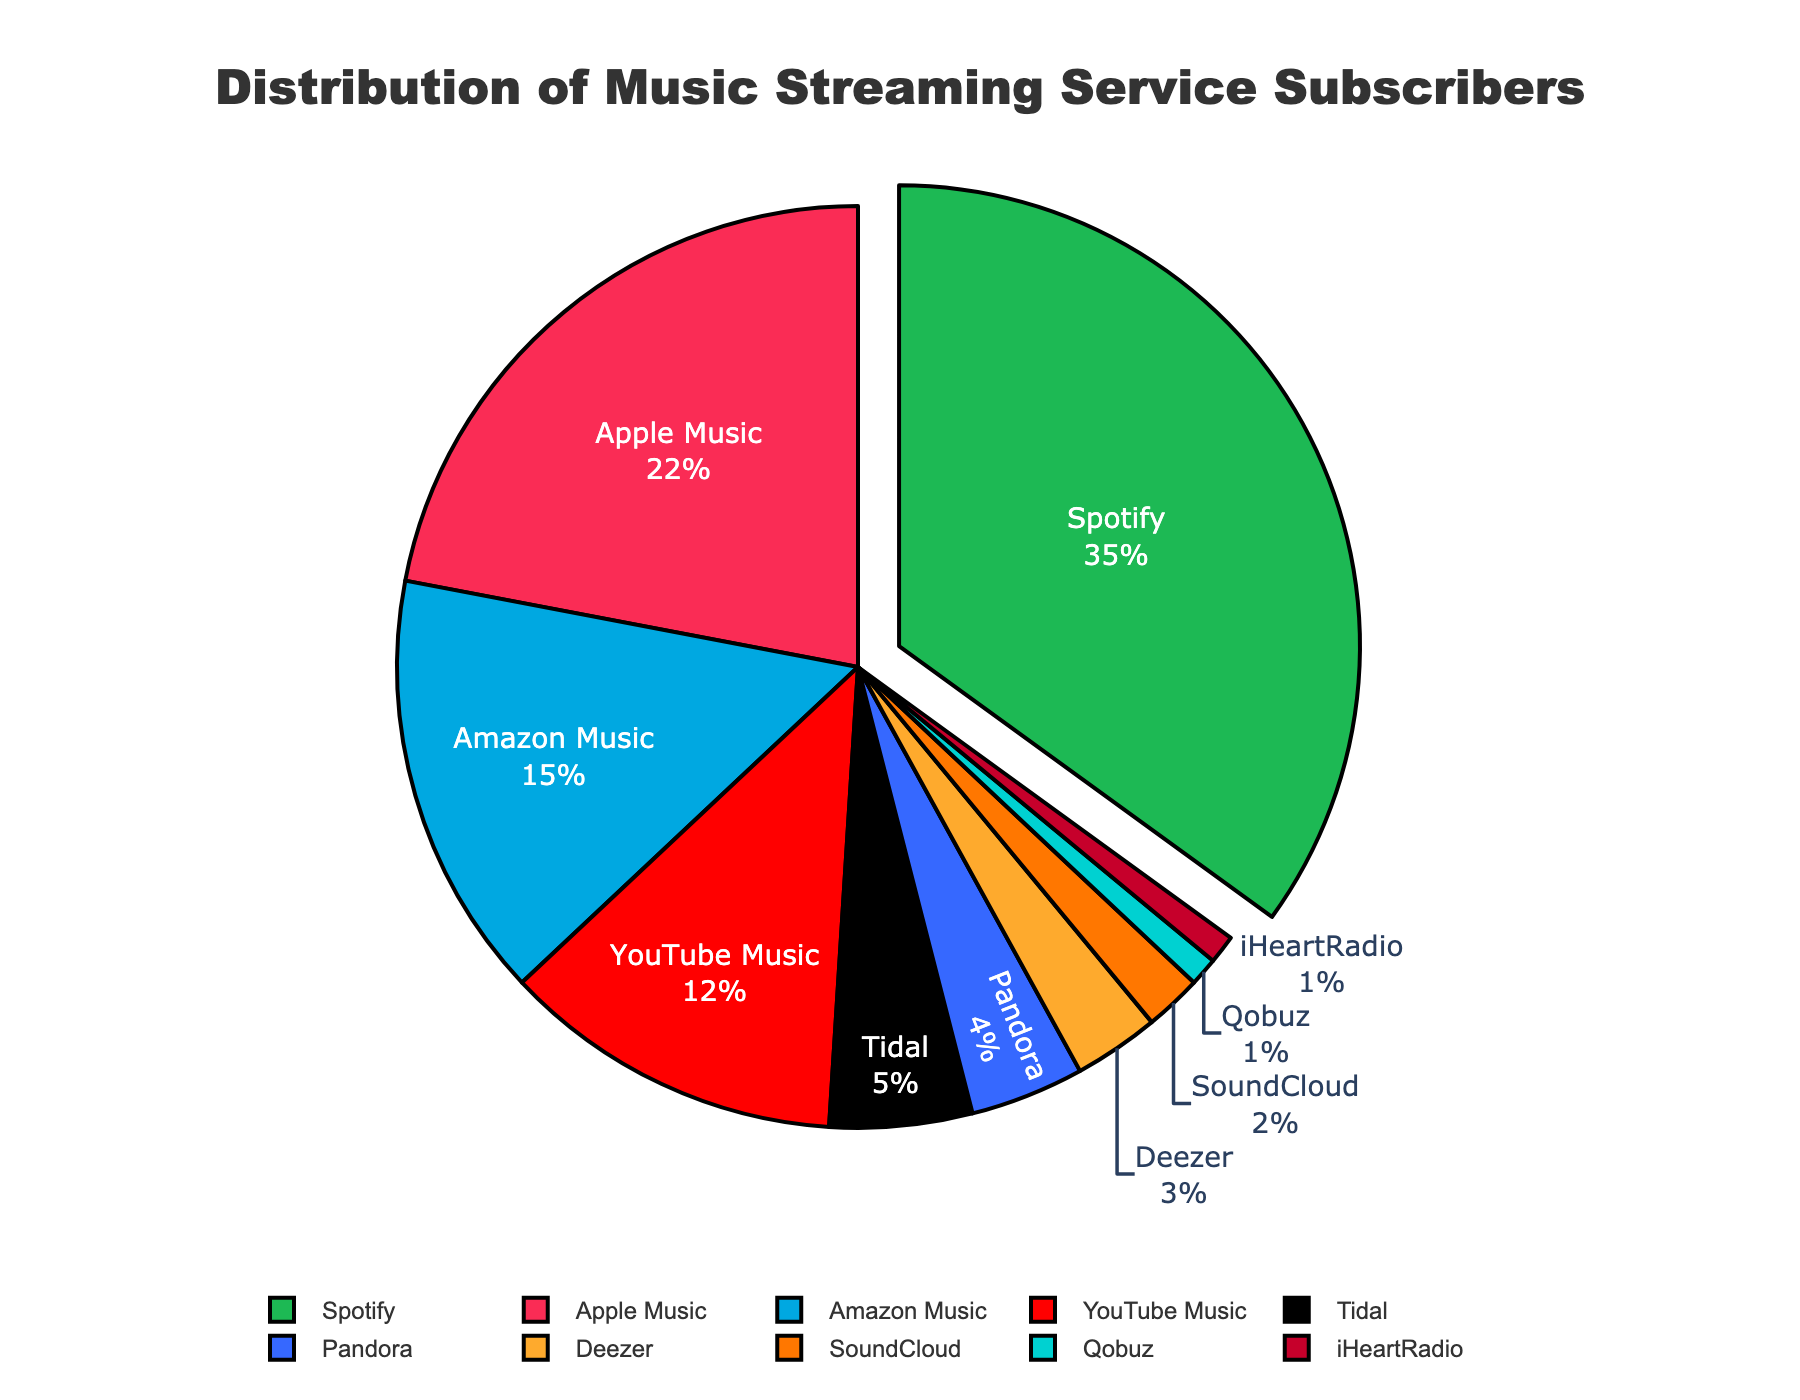What percentage of subscribers use Spotify? Spotify is represented by the largest pie slice. The label on the slice indicates that Spotify has 35% of the subscribers.
Answer: 35% Which platform has the smallest percentage of subscribers? The smallest slice, indicated by the label, corresponds to Qobuz and iHeartRadio, each with 1% of the subscribers.
Answer: Qobuz and iHeartRadio How many more subscribers does Spotify have compared to Apple Music? Spotify has 35 subscribers, and Apple Music has 22 subscribers. The difference is found by subtracting the number of Apple Music subscribers from that of Spotify: 35 - 22 = 13.
Answer: 13 Which three platforms have the highest number of subscribers? The slices can be ranked by their sizes. The largest three slices, indicated by the labels, are Spotify (35), Apple Music (22), and Amazon Music (15).
Answer: Spotify, Apple Music, Amazon Music What is the total number of subscribers for YouTube Music, Tidal, and Pandora combined? YouTube Music has 12 subscribers, Tidal has 5 subscribers, and Pandora has 4 subscribers. Their total is given by summing these values: 12 + 5 + 4 = 21.
Answer: 21 Which platform has more subscribers: Amazon Music or YouTube Music? The Amazon Music slice is larger and marked with 15 subscribers, while YouTube Music is marked with 12.
Answer: Amazon Music How many percent of subscribers use either SoundCloud or Deezer? SoundCloud has 2 subscribers, and Deezer has 3. First, add these numbers to get the total: 2 + 3 = 5. The overall subscriber count is 100 (since these are percentages). (5 / 100) * 100 = 5%.
Answer: 5% What is the combined percentage of subscribers for Spotify and Apple Music? Spotify has 35%, and Apple Music has 22%. Their combined percentage is 35% + 22% = 57%.
Answer: 57% If you combined Qobuz, Deezer, and Tidal's subscribers, how would their total compare to that of Apple Music? Qobuz has 1 subscriber, Deezer has 3, and Tidal has 5. Their combined total is 1 + 3 + 5 = 9, which is less than Apple Music's 22 subscribers.
Answer: Apple Music has more Which platform(s) have a higher subscriber count than Tidal but less than YouTube Music? Tidal has 5 subscribers, and YouTube Music has 12. Platforms with subscribers more than 5 but less than 12 are Amazon Music (15) and Pandora (4).
Answer: None 